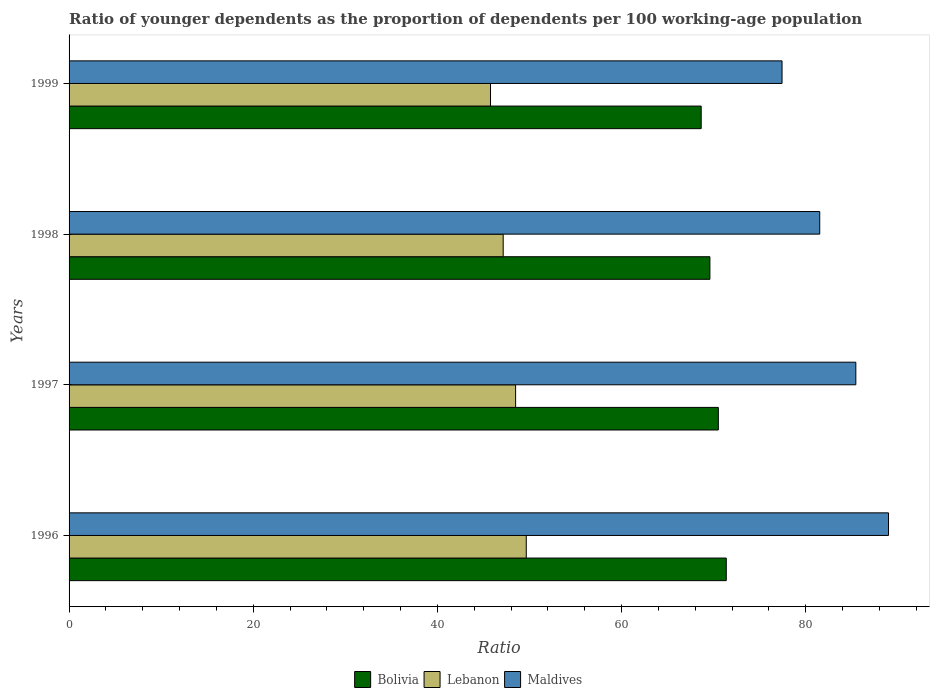How many bars are there on the 3rd tick from the top?
Your answer should be compact. 3. What is the age dependency ratio(young) in Maldives in 1997?
Provide a succinct answer. 85.44. Across all years, what is the maximum age dependency ratio(young) in Bolivia?
Keep it short and to the point. 71.37. Across all years, what is the minimum age dependency ratio(young) in Bolivia?
Your answer should be very brief. 68.64. In which year was the age dependency ratio(young) in Bolivia maximum?
Offer a terse response. 1996. What is the total age dependency ratio(young) in Lebanon in the graph?
Make the answer very short. 191.04. What is the difference between the age dependency ratio(young) in Maldives in 1997 and that in 1998?
Offer a terse response. 3.92. What is the difference between the age dependency ratio(young) in Bolivia in 1998 and the age dependency ratio(young) in Lebanon in 1999?
Your answer should be compact. 23.82. What is the average age dependency ratio(young) in Bolivia per year?
Provide a succinct answer. 70.03. In the year 1998, what is the difference between the age dependency ratio(young) in Maldives and age dependency ratio(young) in Lebanon?
Provide a short and direct response. 34.37. What is the ratio of the age dependency ratio(young) in Maldives in 1996 to that in 1997?
Your answer should be very brief. 1.04. Is the difference between the age dependency ratio(young) in Maldives in 1996 and 1998 greater than the difference between the age dependency ratio(young) in Lebanon in 1996 and 1998?
Keep it short and to the point. Yes. What is the difference between the highest and the second highest age dependency ratio(young) in Bolivia?
Offer a terse response. 0.86. What is the difference between the highest and the lowest age dependency ratio(young) in Maldives?
Keep it short and to the point. 11.56. In how many years, is the age dependency ratio(young) in Maldives greater than the average age dependency ratio(young) in Maldives taken over all years?
Offer a terse response. 2. What does the 3rd bar from the bottom in 1998 represents?
Ensure brevity in your answer.  Maldives. What is the difference between two consecutive major ticks on the X-axis?
Your answer should be compact. 20. Does the graph contain grids?
Ensure brevity in your answer.  No. How are the legend labels stacked?
Keep it short and to the point. Horizontal. What is the title of the graph?
Make the answer very short. Ratio of younger dependents as the proportion of dependents per 100 working-age population. Does "Algeria" appear as one of the legend labels in the graph?
Your answer should be very brief. No. What is the label or title of the X-axis?
Your answer should be compact. Ratio. What is the Ratio of Bolivia in 1996?
Offer a very short reply. 71.37. What is the Ratio of Lebanon in 1996?
Ensure brevity in your answer.  49.65. What is the Ratio in Maldives in 1996?
Give a very brief answer. 88.99. What is the Ratio of Bolivia in 1997?
Offer a terse response. 70.5. What is the Ratio of Lebanon in 1997?
Your response must be concise. 48.49. What is the Ratio of Maldives in 1997?
Keep it short and to the point. 85.44. What is the Ratio in Bolivia in 1998?
Ensure brevity in your answer.  69.59. What is the Ratio of Lebanon in 1998?
Your answer should be compact. 47.14. What is the Ratio of Maldives in 1998?
Ensure brevity in your answer.  81.52. What is the Ratio of Bolivia in 1999?
Keep it short and to the point. 68.64. What is the Ratio in Lebanon in 1999?
Offer a very short reply. 45.77. What is the Ratio of Maldives in 1999?
Your answer should be very brief. 77.42. Across all years, what is the maximum Ratio in Bolivia?
Give a very brief answer. 71.37. Across all years, what is the maximum Ratio in Lebanon?
Ensure brevity in your answer.  49.65. Across all years, what is the maximum Ratio of Maldives?
Ensure brevity in your answer.  88.99. Across all years, what is the minimum Ratio of Bolivia?
Make the answer very short. 68.64. Across all years, what is the minimum Ratio in Lebanon?
Give a very brief answer. 45.77. Across all years, what is the minimum Ratio in Maldives?
Make the answer very short. 77.42. What is the total Ratio in Bolivia in the graph?
Provide a short and direct response. 280.1. What is the total Ratio of Lebanon in the graph?
Your response must be concise. 191.04. What is the total Ratio of Maldives in the graph?
Keep it short and to the point. 333.36. What is the difference between the Ratio in Bolivia in 1996 and that in 1997?
Your response must be concise. 0.86. What is the difference between the Ratio in Lebanon in 1996 and that in 1997?
Ensure brevity in your answer.  1.16. What is the difference between the Ratio in Maldives in 1996 and that in 1997?
Provide a short and direct response. 3.55. What is the difference between the Ratio in Bolivia in 1996 and that in 1998?
Ensure brevity in your answer.  1.78. What is the difference between the Ratio of Lebanon in 1996 and that in 1998?
Make the answer very short. 2.51. What is the difference between the Ratio of Maldives in 1996 and that in 1998?
Your answer should be very brief. 7.47. What is the difference between the Ratio of Bolivia in 1996 and that in 1999?
Your answer should be compact. 2.73. What is the difference between the Ratio of Lebanon in 1996 and that in 1999?
Offer a very short reply. 3.88. What is the difference between the Ratio of Maldives in 1996 and that in 1999?
Give a very brief answer. 11.56. What is the difference between the Ratio of Bolivia in 1997 and that in 1998?
Make the answer very short. 0.92. What is the difference between the Ratio in Lebanon in 1997 and that in 1998?
Offer a terse response. 1.35. What is the difference between the Ratio of Maldives in 1997 and that in 1998?
Offer a terse response. 3.92. What is the difference between the Ratio of Bolivia in 1997 and that in 1999?
Offer a very short reply. 1.86. What is the difference between the Ratio in Lebanon in 1997 and that in 1999?
Your answer should be compact. 2.72. What is the difference between the Ratio in Maldives in 1997 and that in 1999?
Provide a succinct answer. 8.01. What is the difference between the Ratio in Bolivia in 1998 and that in 1999?
Make the answer very short. 0.95. What is the difference between the Ratio of Lebanon in 1998 and that in 1999?
Keep it short and to the point. 1.37. What is the difference between the Ratio of Maldives in 1998 and that in 1999?
Ensure brevity in your answer.  4.09. What is the difference between the Ratio of Bolivia in 1996 and the Ratio of Lebanon in 1997?
Provide a short and direct response. 22.88. What is the difference between the Ratio of Bolivia in 1996 and the Ratio of Maldives in 1997?
Your response must be concise. -14.07. What is the difference between the Ratio of Lebanon in 1996 and the Ratio of Maldives in 1997?
Give a very brief answer. -35.79. What is the difference between the Ratio in Bolivia in 1996 and the Ratio in Lebanon in 1998?
Ensure brevity in your answer.  24.23. What is the difference between the Ratio of Bolivia in 1996 and the Ratio of Maldives in 1998?
Your answer should be compact. -10.15. What is the difference between the Ratio in Lebanon in 1996 and the Ratio in Maldives in 1998?
Your answer should be very brief. -31.87. What is the difference between the Ratio of Bolivia in 1996 and the Ratio of Lebanon in 1999?
Provide a short and direct response. 25.6. What is the difference between the Ratio in Bolivia in 1996 and the Ratio in Maldives in 1999?
Offer a very short reply. -6.05. What is the difference between the Ratio in Lebanon in 1996 and the Ratio in Maldives in 1999?
Your answer should be compact. -27.77. What is the difference between the Ratio in Bolivia in 1997 and the Ratio in Lebanon in 1998?
Your answer should be compact. 23.36. What is the difference between the Ratio in Bolivia in 1997 and the Ratio in Maldives in 1998?
Offer a very short reply. -11.01. What is the difference between the Ratio of Lebanon in 1997 and the Ratio of Maldives in 1998?
Make the answer very short. -33.03. What is the difference between the Ratio of Bolivia in 1997 and the Ratio of Lebanon in 1999?
Keep it short and to the point. 24.74. What is the difference between the Ratio in Bolivia in 1997 and the Ratio in Maldives in 1999?
Keep it short and to the point. -6.92. What is the difference between the Ratio in Lebanon in 1997 and the Ratio in Maldives in 1999?
Offer a very short reply. -28.93. What is the difference between the Ratio in Bolivia in 1998 and the Ratio in Lebanon in 1999?
Your response must be concise. 23.82. What is the difference between the Ratio in Bolivia in 1998 and the Ratio in Maldives in 1999?
Your answer should be compact. -7.83. What is the difference between the Ratio of Lebanon in 1998 and the Ratio of Maldives in 1999?
Your answer should be compact. -30.28. What is the average Ratio in Bolivia per year?
Offer a terse response. 70.03. What is the average Ratio of Lebanon per year?
Give a very brief answer. 47.76. What is the average Ratio in Maldives per year?
Give a very brief answer. 83.34. In the year 1996, what is the difference between the Ratio in Bolivia and Ratio in Lebanon?
Provide a succinct answer. 21.72. In the year 1996, what is the difference between the Ratio of Bolivia and Ratio of Maldives?
Give a very brief answer. -17.62. In the year 1996, what is the difference between the Ratio of Lebanon and Ratio of Maldives?
Keep it short and to the point. -39.34. In the year 1997, what is the difference between the Ratio in Bolivia and Ratio in Lebanon?
Offer a terse response. 22.01. In the year 1997, what is the difference between the Ratio of Bolivia and Ratio of Maldives?
Make the answer very short. -14.93. In the year 1997, what is the difference between the Ratio of Lebanon and Ratio of Maldives?
Offer a very short reply. -36.95. In the year 1998, what is the difference between the Ratio in Bolivia and Ratio in Lebanon?
Offer a very short reply. 22.45. In the year 1998, what is the difference between the Ratio in Bolivia and Ratio in Maldives?
Make the answer very short. -11.93. In the year 1998, what is the difference between the Ratio of Lebanon and Ratio of Maldives?
Offer a very short reply. -34.37. In the year 1999, what is the difference between the Ratio of Bolivia and Ratio of Lebanon?
Your answer should be compact. 22.88. In the year 1999, what is the difference between the Ratio of Bolivia and Ratio of Maldives?
Ensure brevity in your answer.  -8.78. In the year 1999, what is the difference between the Ratio of Lebanon and Ratio of Maldives?
Give a very brief answer. -31.66. What is the ratio of the Ratio in Bolivia in 1996 to that in 1997?
Keep it short and to the point. 1.01. What is the ratio of the Ratio in Lebanon in 1996 to that in 1997?
Keep it short and to the point. 1.02. What is the ratio of the Ratio in Maldives in 1996 to that in 1997?
Keep it short and to the point. 1.04. What is the ratio of the Ratio in Bolivia in 1996 to that in 1998?
Keep it short and to the point. 1.03. What is the ratio of the Ratio of Lebanon in 1996 to that in 1998?
Provide a succinct answer. 1.05. What is the ratio of the Ratio of Maldives in 1996 to that in 1998?
Offer a terse response. 1.09. What is the ratio of the Ratio in Bolivia in 1996 to that in 1999?
Ensure brevity in your answer.  1.04. What is the ratio of the Ratio of Lebanon in 1996 to that in 1999?
Make the answer very short. 1.08. What is the ratio of the Ratio of Maldives in 1996 to that in 1999?
Your answer should be compact. 1.15. What is the ratio of the Ratio of Bolivia in 1997 to that in 1998?
Your response must be concise. 1.01. What is the ratio of the Ratio of Lebanon in 1997 to that in 1998?
Keep it short and to the point. 1.03. What is the ratio of the Ratio of Maldives in 1997 to that in 1998?
Make the answer very short. 1.05. What is the ratio of the Ratio in Bolivia in 1997 to that in 1999?
Make the answer very short. 1.03. What is the ratio of the Ratio of Lebanon in 1997 to that in 1999?
Offer a very short reply. 1.06. What is the ratio of the Ratio of Maldives in 1997 to that in 1999?
Your answer should be compact. 1.1. What is the ratio of the Ratio of Bolivia in 1998 to that in 1999?
Provide a succinct answer. 1.01. What is the ratio of the Ratio in Maldives in 1998 to that in 1999?
Make the answer very short. 1.05. What is the difference between the highest and the second highest Ratio in Bolivia?
Give a very brief answer. 0.86. What is the difference between the highest and the second highest Ratio in Lebanon?
Offer a terse response. 1.16. What is the difference between the highest and the second highest Ratio of Maldives?
Offer a very short reply. 3.55. What is the difference between the highest and the lowest Ratio of Bolivia?
Your answer should be compact. 2.73. What is the difference between the highest and the lowest Ratio in Lebanon?
Make the answer very short. 3.88. What is the difference between the highest and the lowest Ratio in Maldives?
Your answer should be very brief. 11.56. 